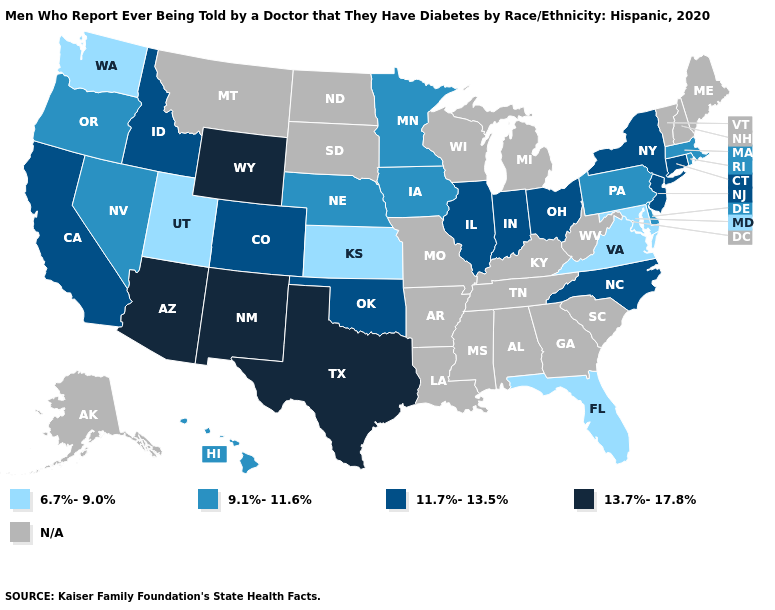What is the value of Missouri?
Write a very short answer. N/A. What is the lowest value in states that border Arkansas?
Short answer required. 11.7%-13.5%. What is the highest value in the South ?
Keep it brief. 13.7%-17.8%. What is the value of Texas?
Quick response, please. 13.7%-17.8%. Which states have the lowest value in the USA?
Concise answer only. Florida, Kansas, Maryland, Utah, Virginia, Washington. Does Maryland have the lowest value in the USA?
Answer briefly. Yes. Does Massachusetts have the lowest value in the USA?
Be succinct. No. What is the highest value in the Northeast ?
Be succinct. 11.7%-13.5%. Name the states that have a value in the range 6.7%-9.0%?
Write a very short answer. Florida, Kansas, Maryland, Utah, Virginia, Washington. Name the states that have a value in the range N/A?
Give a very brief answer. Alabama, Alaska, Arkansas, Georgia, Kentucky, Louisiana, Maine, Michigan, Mississippi, Missouri, Montana, New Hampshire, North Dakota, South Carolina, South Dakota, Tennessee, Vermont, West Virginia, Wisconsin. What is the value of Pennsylvania?
Answer briefly. 9.1%-11.6%. 